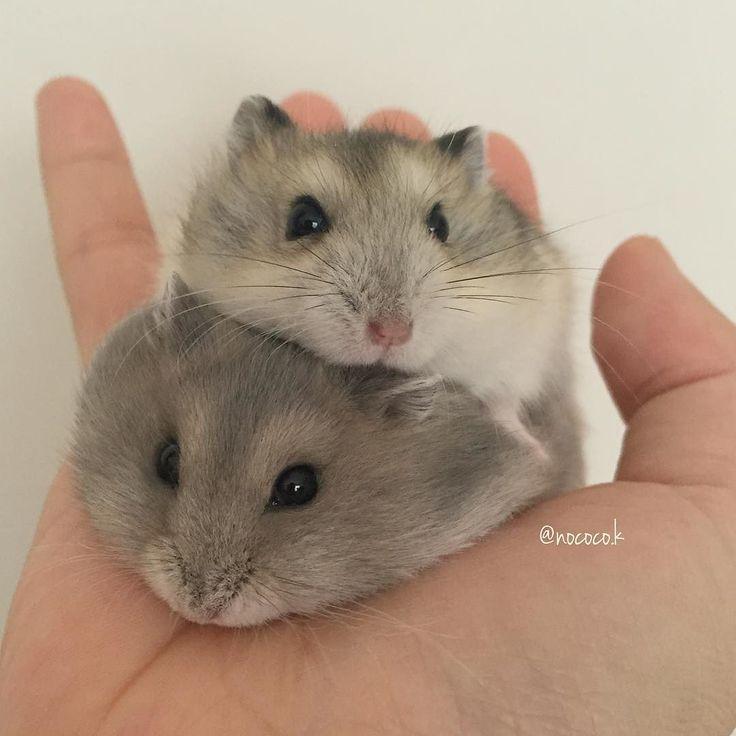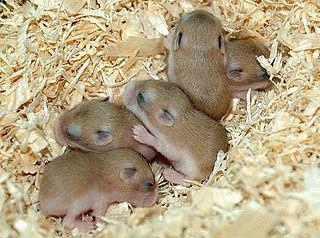The first image is the image on the left, the second image is the image on the right. For the images displayed, is the sentence "One image shows at least one pet rodent on shredded bedding material, and the other image shows a hand holding no more than two pet rodents." factually correct? Answer yes or no. Yes. 